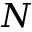Convert formula to latex. <formula><loc_0><loc_0><loc_500><loc_500>N</formula> 